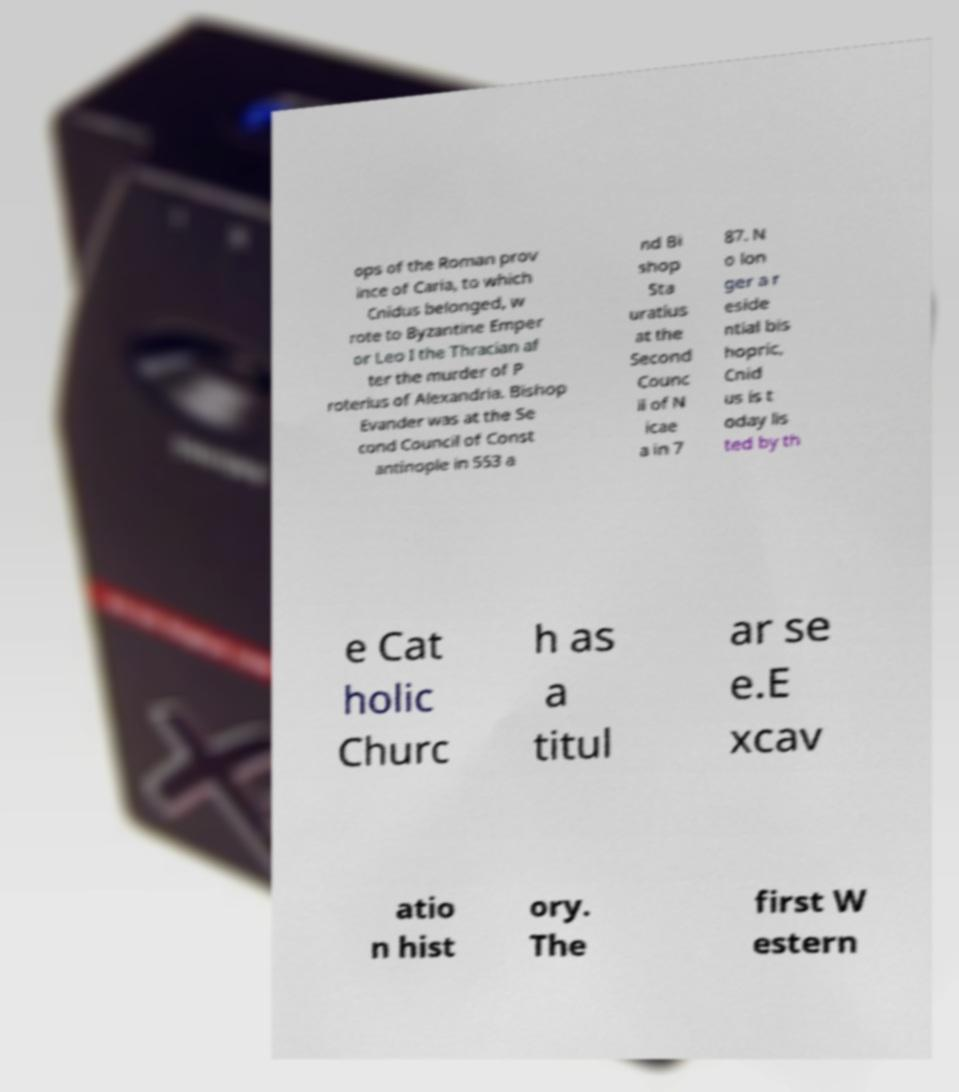There's text embedded in this image that I need extracted. Can you transcribe it verbatim? ops of the Roman prov ince of Caria, to which Cnidus belonged, w rote to Byzantine Emper or Leo I the Thracian af ter the murder of P roterius of Alexandria. Bishop Evander was at the Se cond Council of Const antinople in 553 a nd Bi shop Sta uratius at the Second Counc il of N icae a in 7 87. N o lon ger a r eside ntial bis hopric, Cnid us is t oday lis ted by th e Cat holic Churc h as a titul ar se e.E xcav atio n hist ory. The first W estern 